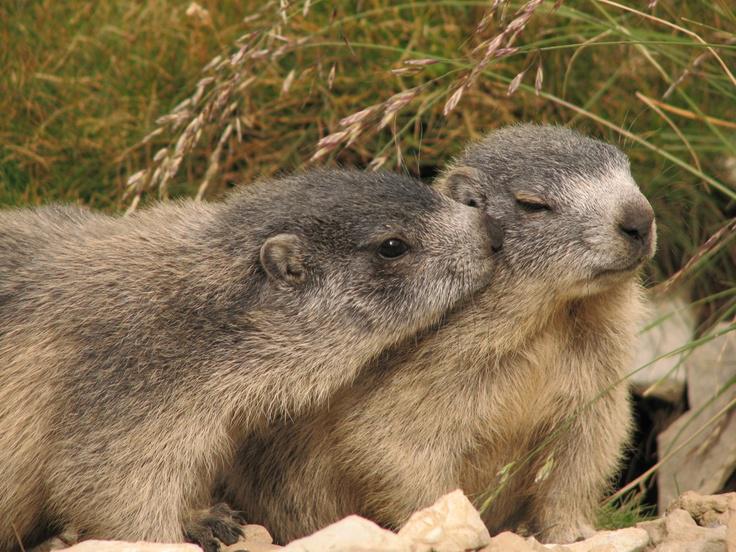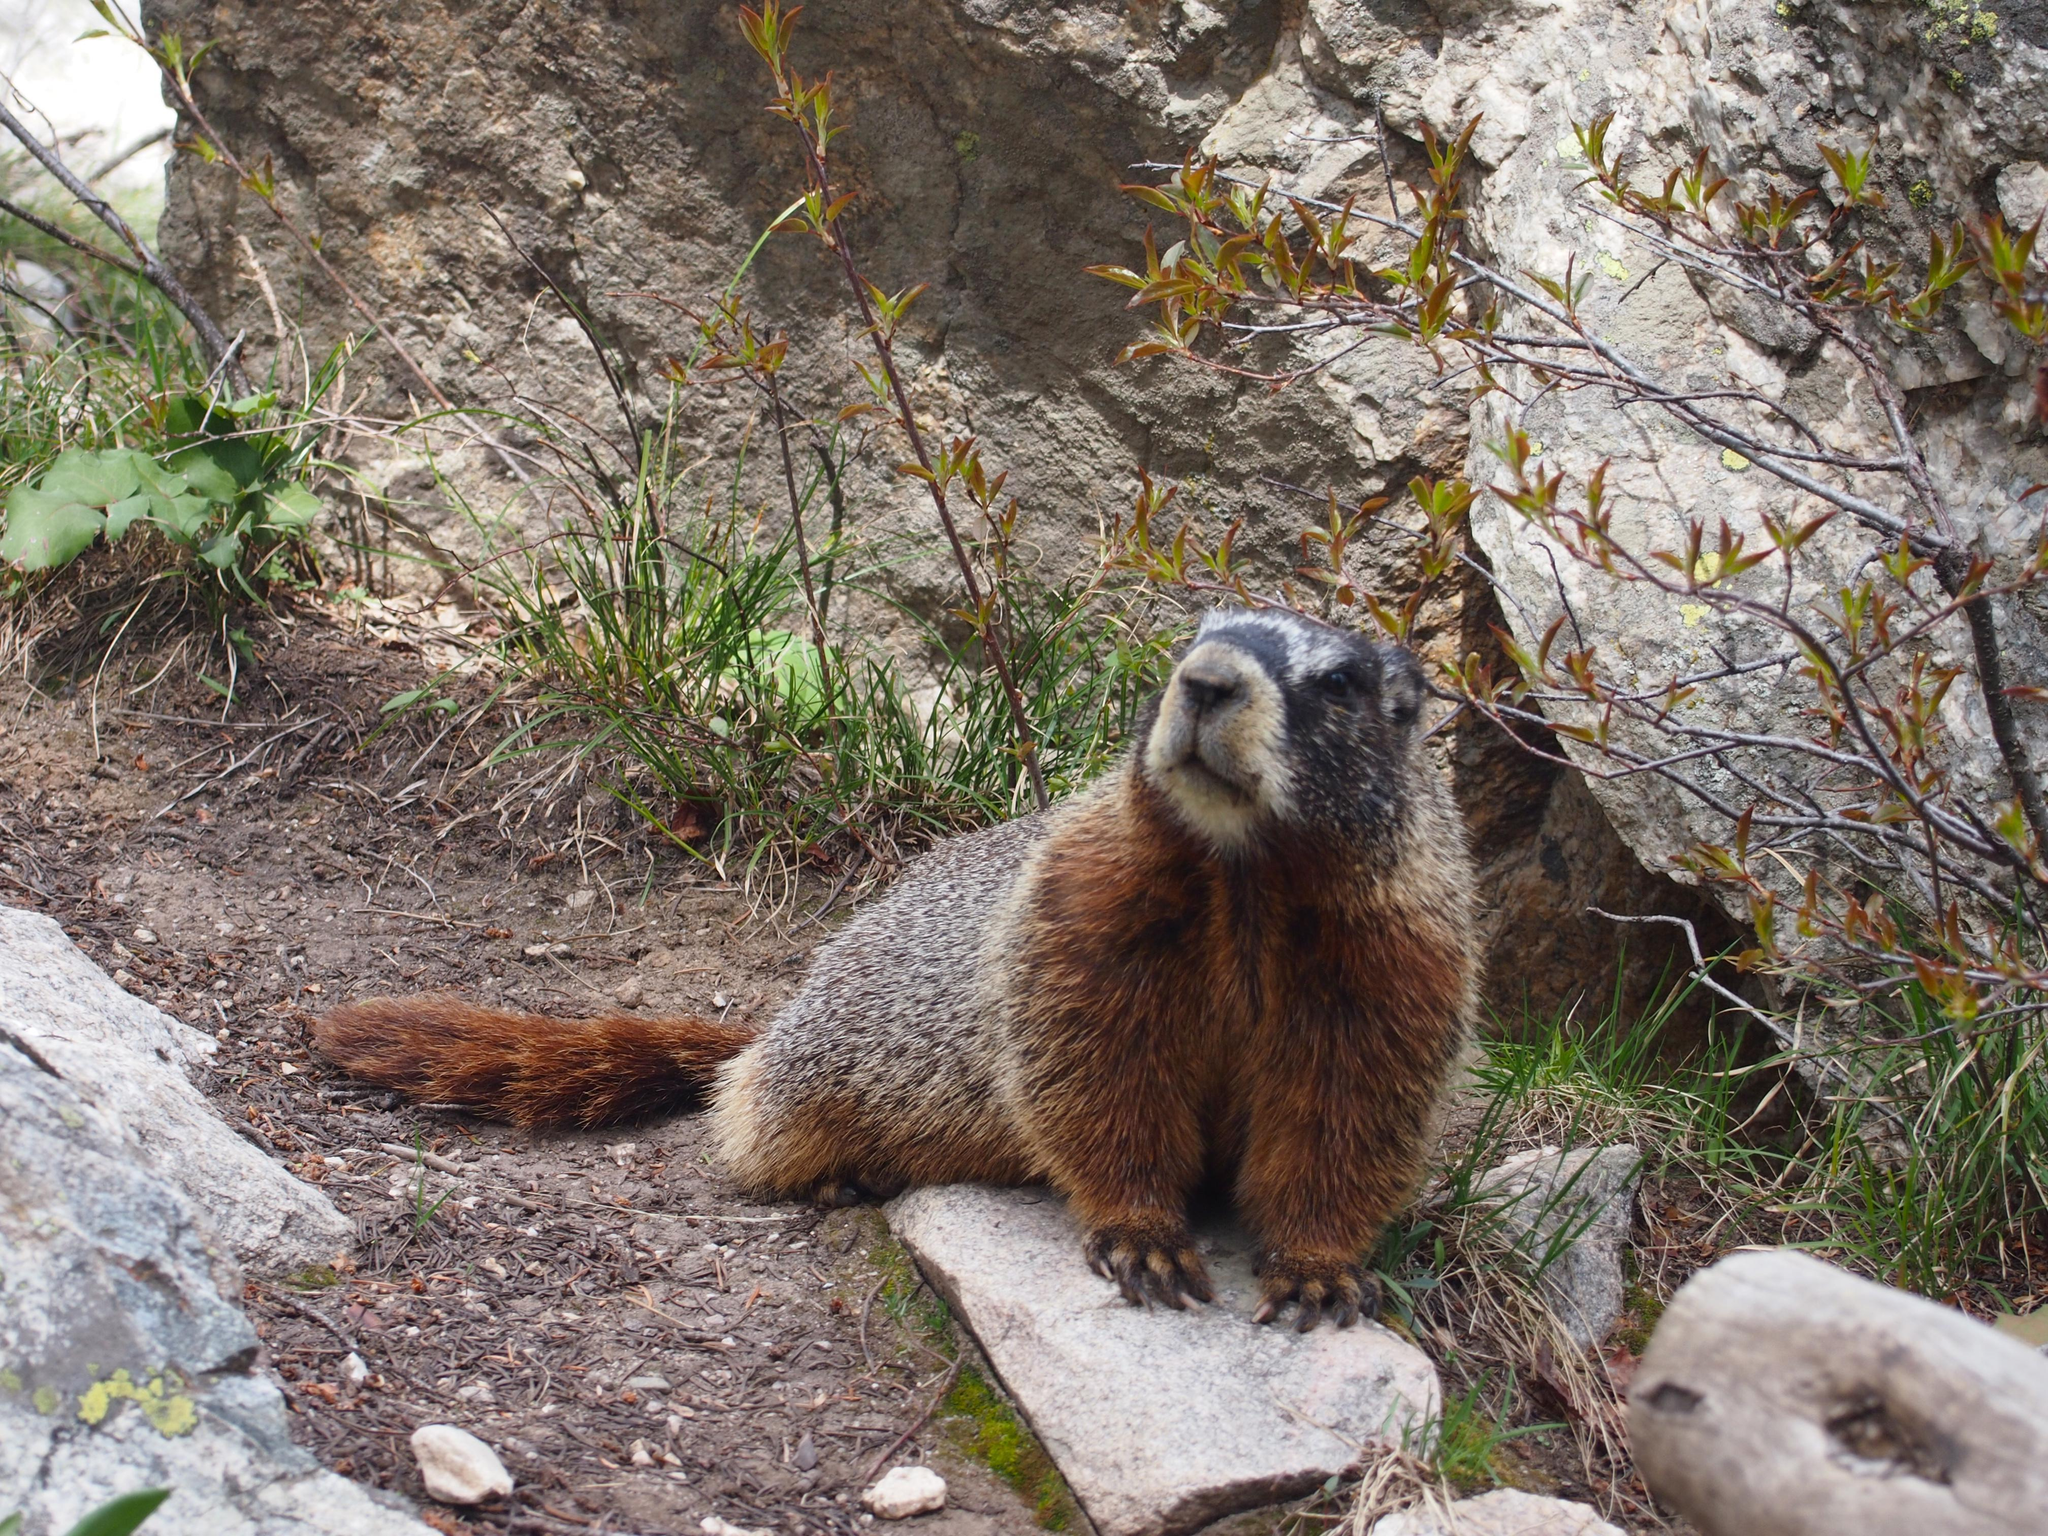The first image is the image on the left, the second image is the image on the right. Given the left and right images, does the statement "Two marmots are in contact in a nuzzling pose in one image." hold true? Answer yes or no. Yes. The first image is the image on the left, the second image is the image on the right. Evaluate the accuracy of this statement regarding the images: "there are at least two animals eating in the image on the right.". Is it true? Answer yes or no. No. 